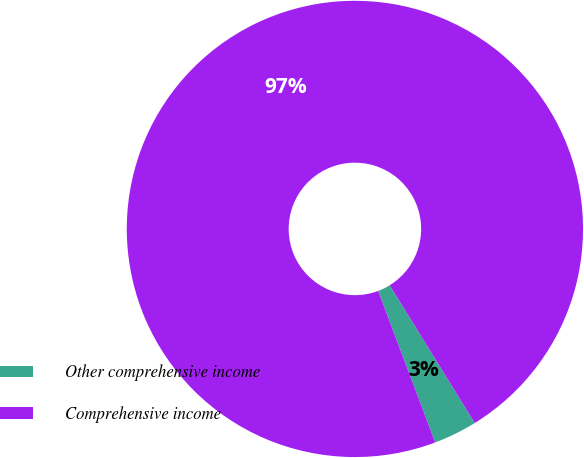Convert chart to OTSL. <chart><loc_0><loc_0><loc_500><loc_500><pie_chart><fcel>Other comprehensive income<fcel>Comprehensive income<nl><fcel>3.08%<fcel>96.92%<nl></chart> 